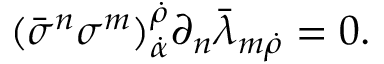<formula> <loc_0><loc_0><loc_500><loc_500>( \bar { \sigma } ^ { n } \sigma ^ { m } ) _ { \dot { \alpha } } ^ { \dot { \rho } } \partial _ { n } \bar { \lambda } _ { m \dot { \rho } } = 0 .</formula> 